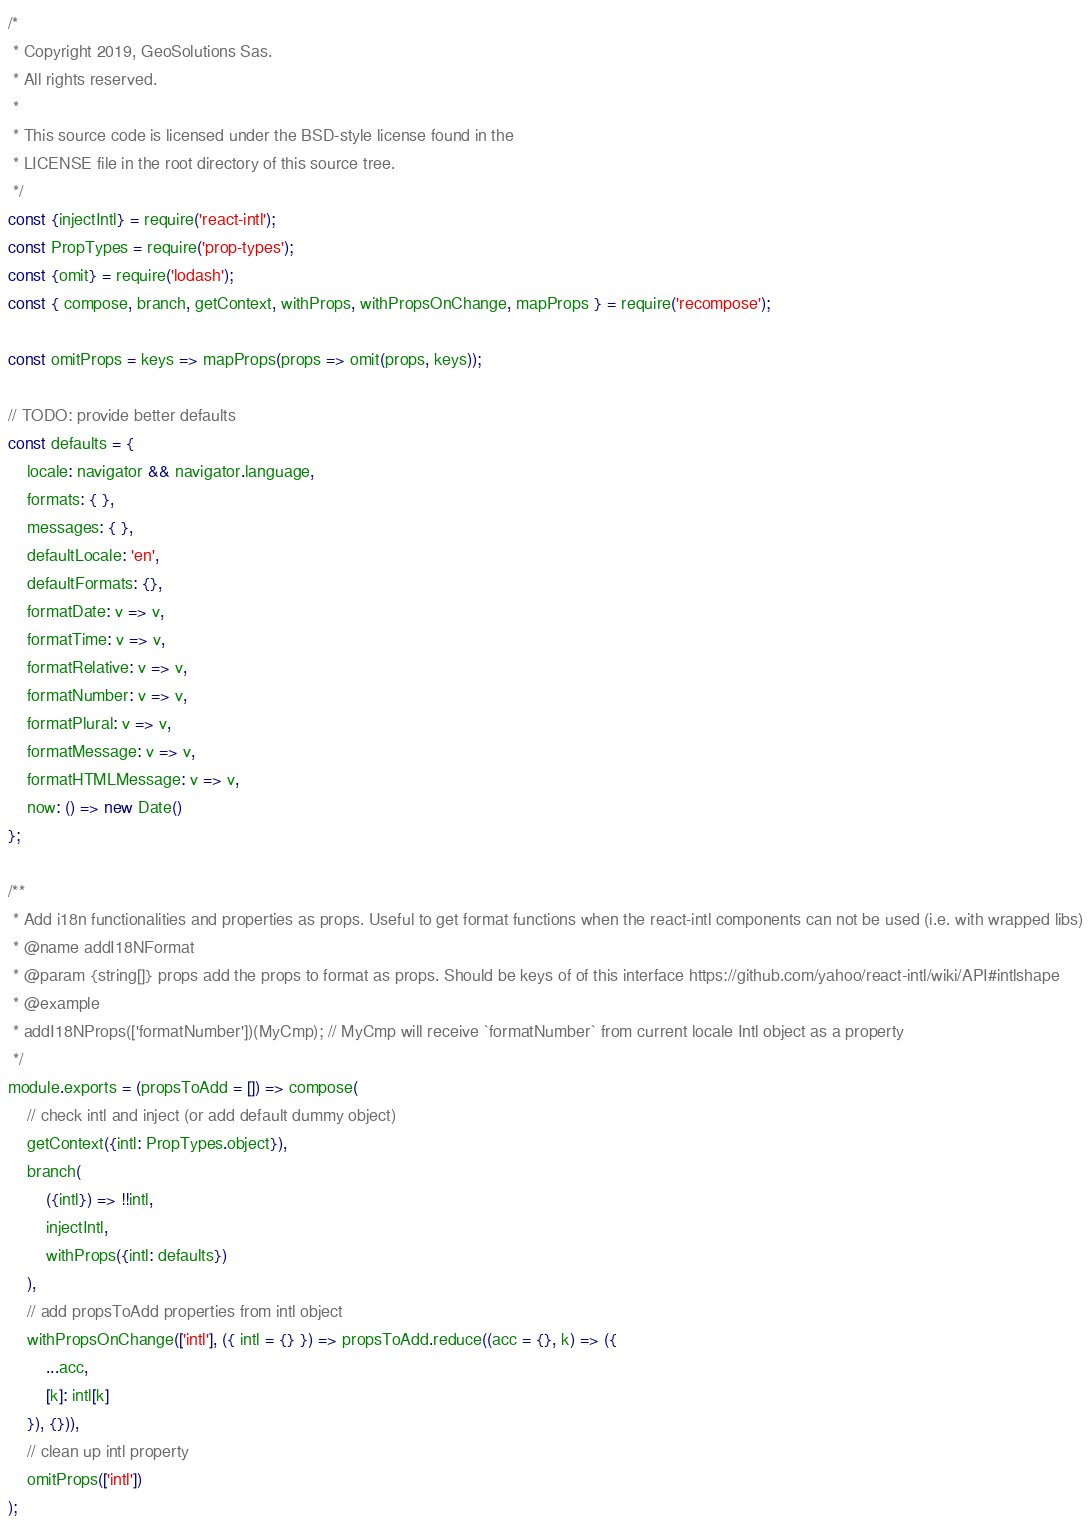Convert code to text. <code><loc_0><loc_0><loc_500><loc_500><_JavaScript_>/*
 * Copyright 2019, GeoSolutions Sas.
 * All rights reserved.
 *
 * This source code is licensed under the BSD-style license found in the
 * LICENSE file in the root directory of this source tree.
 */
const {injectIntl} = require('react-intl');
const PropTypes = require('prop-types');
const {omit} = require('lodash');
const { compose, branch, getContext, withProps, withPropsOnChange, mapProps } = require('recompose');

const omitProps = keys => mapProps(props => omit(props, keys));

// TODO: provide better defaults
const defaults = {
    locale: navigator && navigator.language,
    formats: { },
    messages: { },
    defaultLocale: 'en',
    defaultFormats: {},
    formatDate: v => v,
    formatTime: v => v,
    formatRelative: v => v,
    formatNumber: v => v,
    formatPlural: v => v,
    formatMessage: v => v,
    formatHTMLMessage: v => v,
    now: () => new Date()
};

/**
 * Add i18n functionalities and properties as props. Useful to get format functions when the react-intl components can not be used (i.e. with wrapped libs)
 * @name addI18NFormat
 * @param {string[]} props add the props to format as props. Should be keys of of this interface https://github.com/yahoo/react-intl/wiki/API#intlshape
 * @example
 * addI18NProps(['formatNumber'])(MyCmp); // MyCmp will receive `formatNumber` from current locale Intl object as a property
 */
module.exports = (propsToAdd = []) => compose(
    // check intl and inject (or add default dummy object)
    getContext({intl: PropTypes.object}),
    branch(
        ({intl}) => !!intl,
        injectIntl,
        withProps({intl: defaults})
    ),
    // add propsToAdd properties from intl object
    withPropsOnChange(['intl'], ({ intl = {} }) => propsToAdd.reduce((acc = {}, k) => ({
        ...acc,
        [k]: intl[k]
    }), {})),
    // clean up intl property
    omitProps(['intl'])
);
</code> 